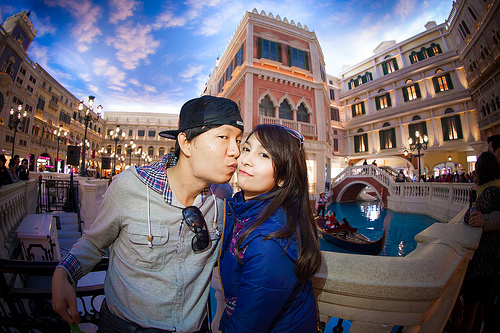<image>
Is the man next to the women? Yes. The man is positioned adjacent to the women, located nearby in the same general area. Is there a gondola in front of the bridge? Yes. The gondola is positioned in front of the bridge, appearing closer to the camera viewpoint. 